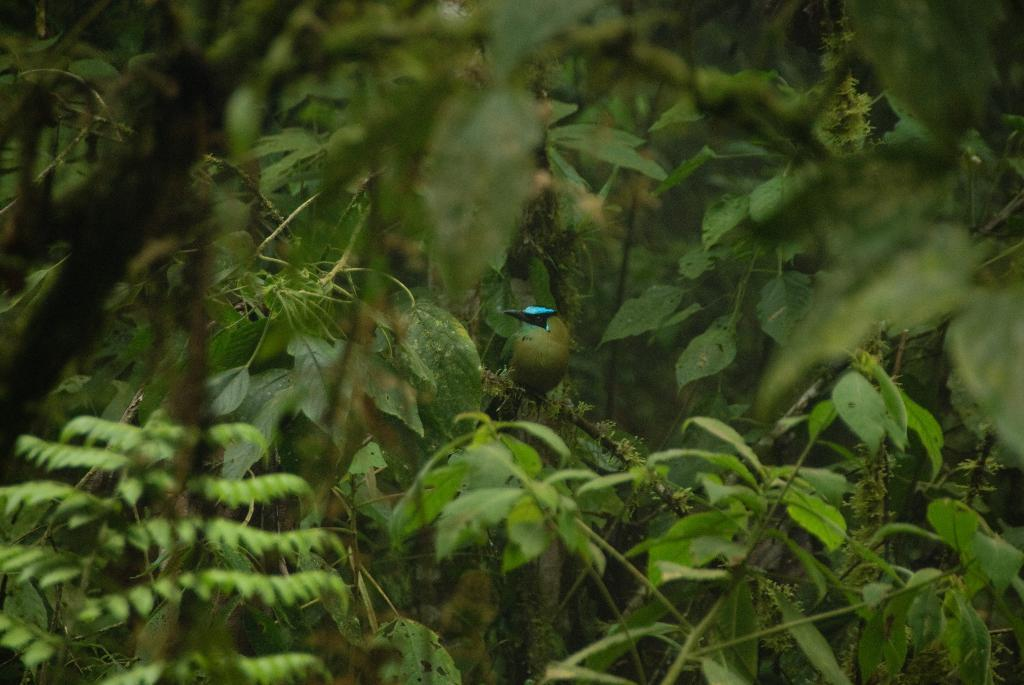What type of animal can be seen in the image? There is a bird in the image. Where is the bird located? The bird is sitting on a tree. What is the color of the tree? The tree is green. What type of impulse can be seen affecting the bird in the image? There is no impulse affecting the bird in the image; it is simply sitting on the tree. What type of clouds can be seen in the image? There are no clouds visible in the image; it only shows a bird sitting on a tree. 